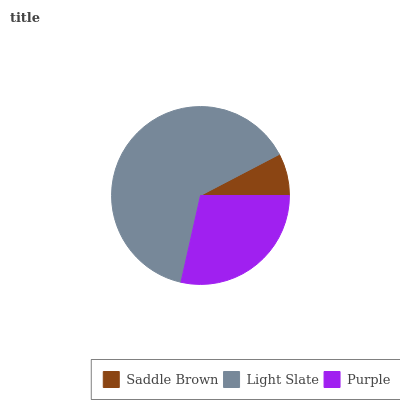Is Saddle Brown the minimum?
Answer yes or no. Yes. Is Light Slate the maximum?
Answer yes or no. Yes. Is Purple the minimum?
Answer yes or no. No. Is Purple the maximum?
Answer yes or no. No. Is Light Slate greater than Purple?
Answer yes or no. Yes. Is Purple less than Light Slate?
Answer yes or no. Yes. Is Purple greater than Light Slate?
Answer yes or no. No. Is Light Slate less than Purple?
Answer yes or no. No. Is Purple the high median?
Answer yes or no. Yes. Is Purple the low median?
Answer yes or no. Yes. Is Saddle Brown the high median?
Answer yes or no. No. Is Saddle Brown the low median?
Answer yes or no. No. 